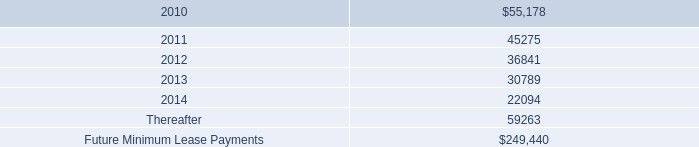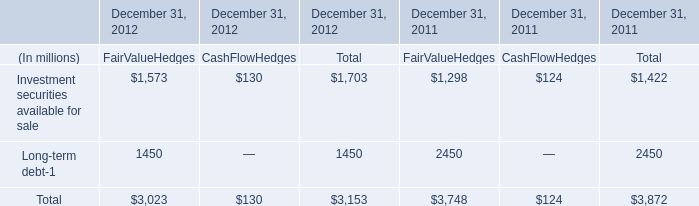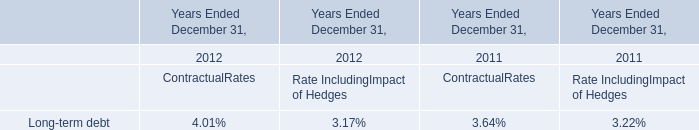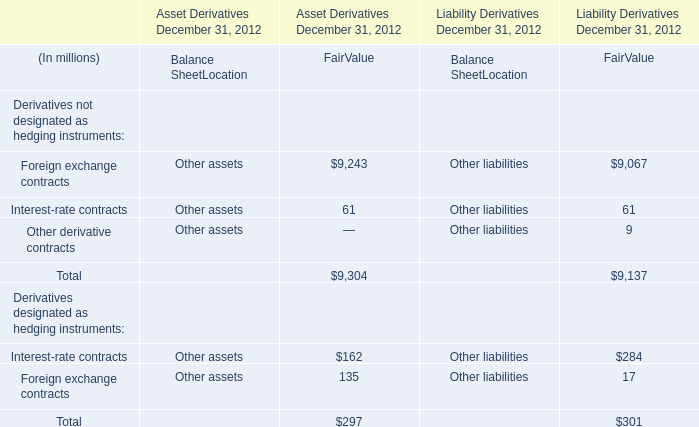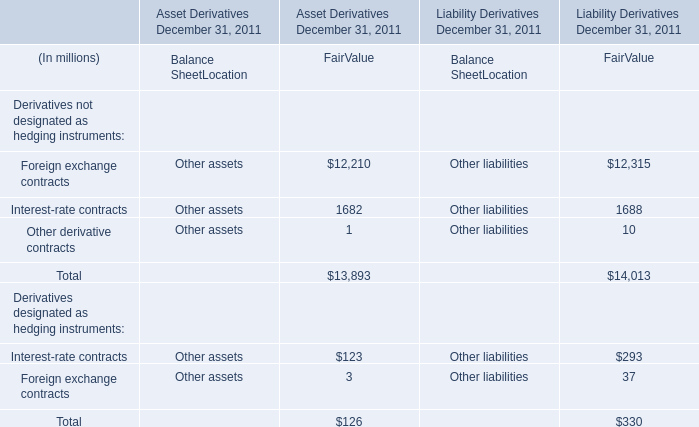What is the highest Fair Value for Derivatives designated as hedging instruments:Interest-rate contracts as As the chart 3 shows? (in million) 
Answer: 284. 